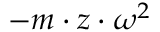Convert formula to latex. <formula><loc_0><loc_0><loc_500><loc_500>- m \cdot z \cdot \omega ^ { 2 }</formula> 